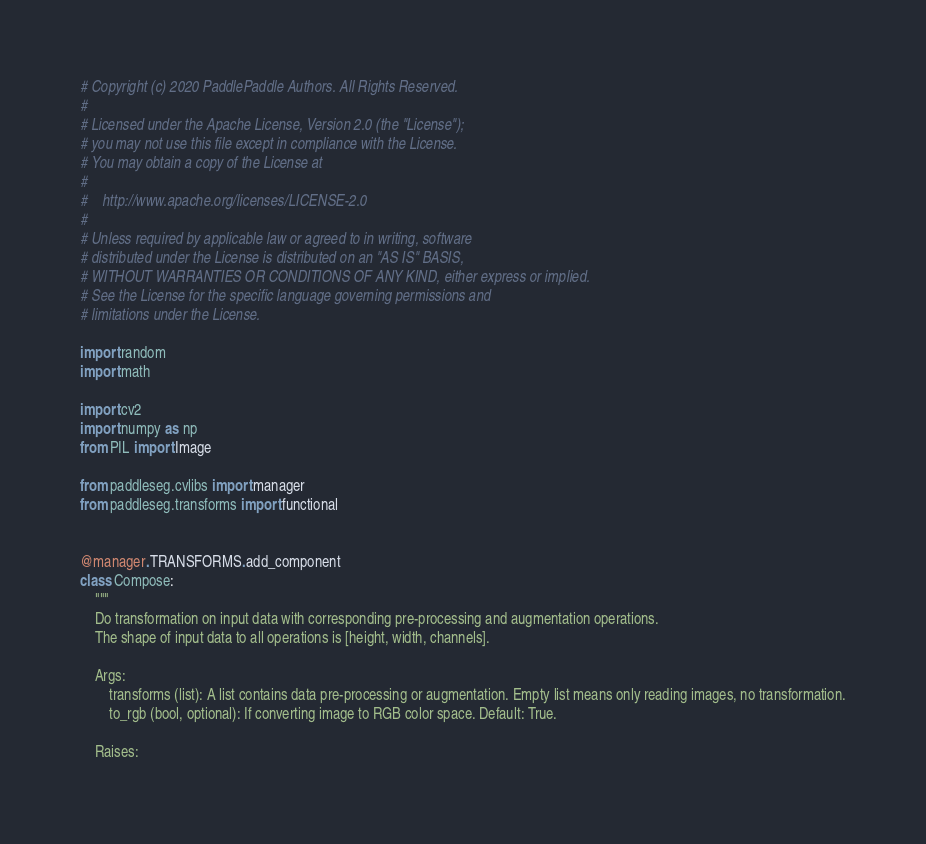<code> <loc_0><loc_0><loc_500><loc_500><_Python_># Copyright (c) 2020 PaddlePaddle Authors. All Rights Reserved.
#
# Licensed under the Apache License, Version 2.0 (the "License");
# you may not use this file except in compliance with the License.
# You may obtain a copy of the License at
#
#    http://www.apache.org/licenses/LICENSE-2.0
#
# Unless required by applicable law or agreed to in writing, software
# distributed under the License is distributed on an "AS IS" BASIS,
# WITHOUT WARRANTIES OR CONDITIONS OF ANY KIND, either express or implied.
# See the License for the specific language governing permissions and
# limitations under the License.

import random
import math

import cv2
import numpy as np
from PIL import Image

from paddleseg.cvlibs import manager
from paddleseg.transforms import functional


@manager.TRANSFORMS.add_component
class Compose:
    """
    Do transformation on input data with corresponding pre-processing and augmentation operations.
    The shape of input data to all operations is [height, width, channels].

    Args:
        transforms (list): A list contains data pre-processing or augmentation. Empty list means only reading images, no transformation.
        to_rgb (bool, optional): If converting image to RGB color space. Default: True.

    Raises:</code> 